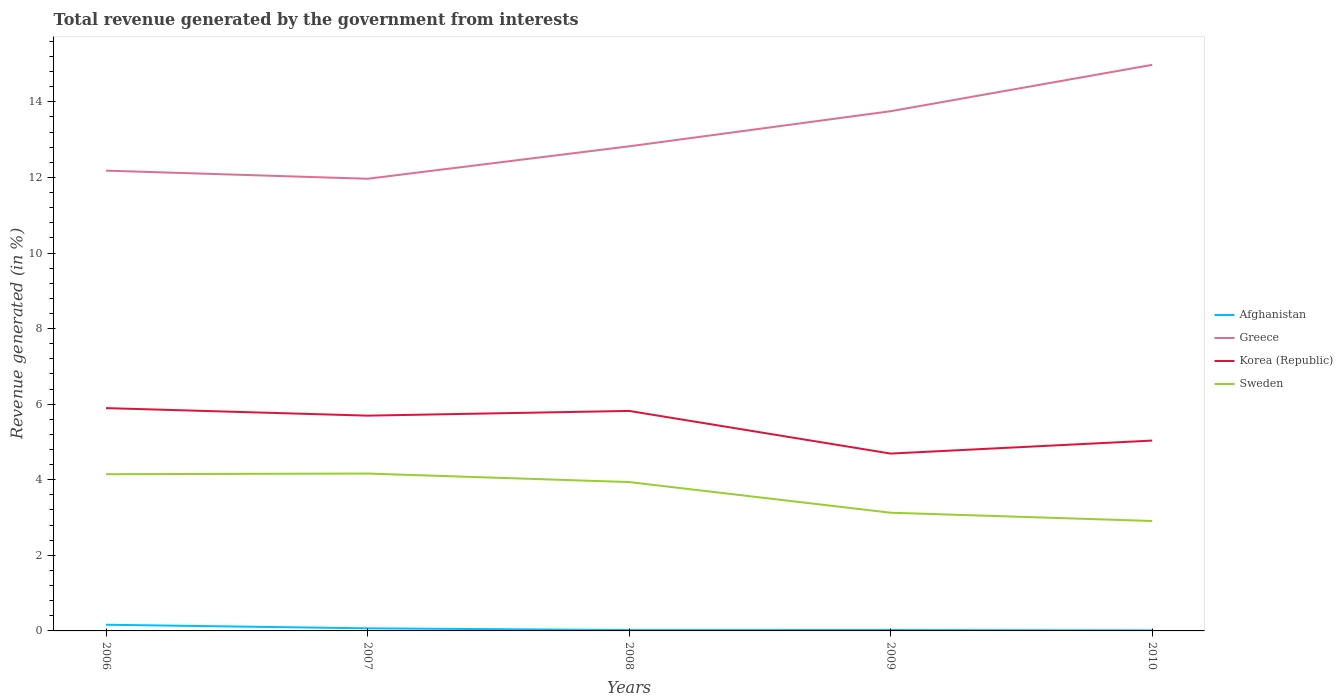Is the number of lines equal to the number of legend labels?
Give a very brief answer. Yes. Across all years, what is the maximum total revenue generated in Afghanistan?
Your response must be concise. 0.01. What is the total total revenue generated in Sweden in the graph?
Your response must be concise. 0.23. What is the difference between the highest and the second highest total revenue generated in Afghanistan?
Provide a succinct answer. 0.15. Is the total revenue generated in Greece strictly greater than the total revenue generated in Sweden over the years?
Your answer should be very brief. No. What is the difference between two consecutive major ticks on the Y-axis?
Offer a very short reply. 2. Are the values on the major ticks of Y-axis written in scientific E-notation?
Make the answer very short. No. Does the graph contain any zero values?
Your answer should be very brief. No. Does the graph contain grids?
Your answer should be very brief. No. Where does the legend appear in the graph?
Your response must be concise. Center right. How many legend labels are there?
Keep it short and to the point. 4. How are the legend labels stacked?
Make the answer very short. Vertical. What is the title of the graph?
Your answer should be compact. Total revenue generated by the government from interests. Does "Iran" appear as one of the legend labels in the graph?
Offer a terse response. No. What is the label or title of the X-axis?
Make the answer very short. Years. What is the label or title of the Y-axis?
Your answer should be compact. Revenue generated (in %). What is the Revenue generated (in %) of Afghanistan in 2006?
Make the answer very short. 0.16. What is the Revenue generated (in %) in Greece in 2006?
Give a very brief answer. 12.18. What is the Revenue generated (in %) of Korea (Republic) in 2006?
Your answer should be compact. 5.9. What is the Revenue generated (in %) of Sweden in 2006?
Provide a succinct answer. 4.15. What is the Revenue generated (in %) in Afghanistan in 2007?
Make the answer very short. 0.07. What is the Revenue generated (in %) of Greece in 2007?
Offer a very short reply. 11.96. What is the Revenue generated (in %) of Korea (Republic) in 2007?
Your response must be concise. 5.7. What is the Revenue generated (in %) of Sweden in 2007?
Offer a very short reply. 4.16. What is the Revenue generated (in %) in Afghanistan in 2008?
Offer a very short reply. 0.02. What is the Revenue generated (in %) in Greece in 2008?
Offer a very short reply. 12.82. What is the Revenue generated (in %) in Korea (Republic) in 2008?
Make the answer very short. 5.82. What is the Revenue generated (in %) of Sweden in 2008?
Make the answer very short. 3.94. What is the Revenue generated (in %) in Afghanistan in 2009?
Ensure brevity in your answer.  0.02. What is the Revenue generated (in %) of Greece in 2009?
Offer a very short reply. 13.75. What is the Revenue generated (in %) in Korea (Republic) in 2009?
Your response must be concise. 4.69. What is the Revenue generated (in %) of Sweden in 2009?
Give a very brief answer. 3.13. What is the Revenue generated (in %) of Afghanistan in 2010?
Ensure brevity in your answer.  0.01. What is the Revenue generated (in %) in Greece in 2010?
Keep it short and to the point. 14.98. What is the Revenue generated (in %) of Korea (Republic) in 2010?
Provide a succinct answer. 5.04. What is the Revenue generated (in %) of Sweden in 2010?
Offer a terse response. 2.91. Across all years, what is the maximum Revenue generated (in %) of Afghanistan?
Make the answer very short. 0.16. Across all years, what is the maximum Revenue generated (in %) in Greece?
Give a very brief answer. 14.98. Across all years, what is the maximum Revenue generated (in %) of Korea (Republic)?
Your response must be concise. 5.9. Across all years, what is the maximum Revenue generated (in %) of Sweden?
Ensure brevity in your answer.  4.16. Across all years, what is the minimum Revenue generated (in %) of Afghanistan?
Offer a very short reply. 0.01. Across all years, what is the minimum Revenue generated (in %) of Greece?
Your response must be concise. 11.96. Across all years, what is the minimum Revenue generated (in %) in Korea (Republic)?
Your answer should be compact. 4.69. Across all years, what is the minimum Revenue generated (in %) in Sweden?
Make the answer very short. 2.91. What is the total Revenue generated (in %) in Afghanistan in the graph?
Your answer should be compact. 0.29. What is the total Revenue generated (in %) of Greece in the graph?
Provide a succinct answer. 65.7. What is the total Revenue generated (in %) of Korea (Republic) in the graph?
Provide a short and direct response. 27.14. What is the total Revenue generated (in %) in Sweden in the graph?
Provide a succinct answer. 18.29. What is the difference between the Revenue generated (in %) in Afghanistan in 2006 and that in 2007?
Keep it short and to the point. 0.1. What is the difference between the Revenue generated (in %) in Greece in 2006 and that in 2007?
Provide a short and direct response. 0.21. What is the difference between the Revenue generated (in %) in Korea (Republic) in 2006 and that in 2007?
Offer a terse response. 0.2. What is the difference between the Revenue generated (in %) in Sweden in 2006 and that in 2007?
Give a very brief answer. -0.02. What is the difference between the Revenue generated (in %) of Afghanistan in 2006 and that in 2008?
Offer a very short reply. 0.14. What is the difference between the Revenue generated (in %) of Greece in 2006 and that in 2008?
Give a very brief answer. -0.64. What is the difference between the Revenue generated (in %) of Korea (Republic) in 2006 and that in 2008?
Your response must be concise. 0.07. What is the difference between the Revenue generated (in %) of Sweden in 2006 and that in 2008?
Your response must be concise. 0.21. What is the difference between the Revenue generated (in %) in Afghanistan in 2006 and that in 2009?
Offer a very short reply. 0.14. What is the difference between the Revenue generated (in %) in Greece in 2006 and that in 2009?
Your answer should be compact. -1.57. What is the difference between the Revenue generated (in %) of Korea (Republic) in 2006 and that in 2009?
Make the answer very short. 1.2. What is the difference between the Revenue generated (in %) of Afghanistan in 2006 and that in 2010?
Offer a terse response. 0.15. What is the difference between the Revenue generated (in %) in Greece in 2006 and that in 2010?
Offer a very short reply. -2.8. What is the difference between the Revenue generated (in %) of Korea (Republic) in 2006 and that in 2010?
Make the answer very short. 0.86. What is the difference between the Revenue generated (in %) in Sweden in 2006 and that in 2010?
Provide a short and direct response. 1.24. What is the difference between the Revenue generated (in %) of Afghanistan in 2007 and that in 2008?
Your answer should be very brief. 0.05. What is the difference between the Revenue generated (in %) in Greece in 2007 and that in 2008?
Provide a succinct answer. -0.86. What is the difference between the Revenue generated (in %) of Korea (Republic) in 2007 and that in 2008?
Keep it short and to the point. -0.12. What is the difference between the Revenue generated (in %) of Sweden in 2007 and that in 2008?
Your answer should be compact. 0.23. What is the difference between the Revenue generated (in %) of Afghanistan in 2007 and that in 2009?
Give a very brief answer. 0.04. What is the difference between the Revenue generated (in %) of Greece in 2007 and that in 2009?
Provide a succinct answer. -1.79. What is the difference between the Revenue generated (in %) in Korea (Republic) in 2007 and that in 2009?
Your response must be concise. 1. What is the difference between the Revenue generated (in %) of Sweden in 2007 and that in 2009?
Provide a short and direct response. 1.04. What is the difference between the Revenue generated (in %) in Afghanistan in 2007 and that in 2010?
Your response must be concise. 0.05. What is the difference between the Revenue generated (in %) of Greece in 2007 and that in 2010?
Offer a very short reply. -3.01. What is the difference between the Revenue generated (in %) of Korea (Republic) in 2007 and that in 2010?
Ensure brevity in your answer.  0.66. What is the difference between the Revenue generated (in %) in Sweden in 2007 and that in 2010?
Make the answer very short. 1.26. What is the difference between the Revenue generated (in %) in Afghanistan in 2008 and that in 2009?
Offer a terse response. -0. What is the difference between the Revenue generated (in %) of Greece in 2008 and that in 2009?
Provide a succinct answer. -0.93. What is the difference between the Revenue generated (in %) in Korea (Republic) in 2008 and that in 2009?
Offer a very short reply. 1.13. What is the difference between the Revenue generated (in %) in Sweden in 2008 and that in 2009?
Your answer should be compact. 0.81. What is the difference between the Revenue generated (in %) in Afghanistan in 2008 and that in 2010?
Offer a terse response. 0.01. What is the difference between the Revenue generated (in %) of Greece in 2008 and that in 2010?
Give a very brief answer. -2.16. What is the difference between the Revenue generated (in %) in Korea (Republic) in 2008 and that in 2010?
Offer a terse response. 0.78. What is the difference between the Revenue generated (in %) in Sweden in 2008 and that in 2010?
Your response must be concise. 1.03. What is the difference between the Revenue generated (in %) in Afghanistan in 2009 and that in 2010?
Your answer should be compact. 0.01. What is the difference between the Revenue generated (in %) of Greece in 2009 and that in 2010?
Your response must be concise. -1.23. What is the difference between the Revenue generated (in %) of Korea (Republic) in 2009 and that in 2010?
Your response must be concise. -0.34. What is the difference between the Revenue generated (in %) of Sweden in 2009 and that in 2010?
Offer a very short reply. 0.22. What is the difference between the Revenue generated (in %) in Afghanistan in 2006 and the Revenue generated (in %) in Greece in 2007?
Keep it short and to the point. -11.8. What is the difference between the Revenue generated (in %) in Afghanistan in 2006 and the Revenue generated (in %) in Korea (Republic) in 2007?
Your answer should be compact. -5.53. What is the difference between the Revenue generated (in %) in Afghanistan in 2006 and the Revenue generated (in %) in Sweden in 2007?
Keep it short and to the point. -4. What is the difference between the Revenue generated (in %) in Greece in 2006 and the Revenue generated (in %) in Korea (Republic) in 2007?
Keep it short and to the point. 6.48. What is the difference between the Revenue generated (in %) of Greece in 2006 and the Revenue generated (in %) of Sweden in 2007?
Your answer should be very brief. 8.01. What is the difference between the Revenue generated (in %) of Korea (Republic) in 2006 and the Revenue generated (in %) of Sweden in 2007?
Your answer should be very brief. 1.73. What is the difference between the Revenue generated (in %) in Afghanistan in 2006 and the Revenue generated (in %) in Greece in 2008?
Ensure brevity in your answer.  -12.66. What is the difference between the Revenue generated (in %) of Afghanistan in 2006 and the Revenue generated (in %) of Korea (Republic) in 2008?
Your answer should be compact. -5.66. What is the difference between the Revenue generated (in %) of Afghanistan in 2006 and the Revenue generated (in %) of Sweden in 2008?
Provide a succinct answer. -3.77. What is the difference between the Revenue generated (in %) of Greece in 2006 and the Revenue generated (in %) of Korea (Republic) in 2008?
Your answer should be very brief. 6.36. What is the difference between the Revenue generated (in %) of Greece in 2006 and the Revenue generated (in %) of Sweden in 2008?
Your response must be concise. 8.24. What is the difference between the Revenue generated (in %) in Korea (Republic) in 2006 and the Revenue generated (in %) in Sweden in 2008?
Offer a very short reply. 1.96. What is the difference between the Revenue generated (in %) of Afghanistan in 2006 and the Revenue generated (in %) of Greece in 2009?
Give a very brief answer. -13.59. What is the difference between the Revenue generated (in %) in Afghanistan in 2006 and the Revenue generated (in %) in Korea (Republic) in 2009?
Ensure brevity in your answer.  -4.53. What is the difference between the Revenue generated (in %) in Afghanistan in 2006 and the Revenue generated (in %) in Sweden in 2009?
Provide a short and direct response. -2.96. What is the difference between the Revenue generated (in %) of Greece in 2006 and the Revenue generated (in %) of Korea (Republic) in 2009?
Your answer should be compact. 7.49. What is the difference between the Revenue generated (in %) in Greece in 2006 and the Revenue generated (in %) in Sweden in 2009?
Keep it short and to the point. 9.05. What is the difference between the Revenue generated (in %) of Korea (Republic) in 2006 and the Revenue generated (in %) of Sweden in 2009?
Provide a short and direct response. 2.77. What is the difference between the Revenue generated (in %) of Afghanistan in 2006 and the Revenue generated (in %) of Greece in 2010?
Offer a very short reply. -14.81. What is the difference between the Revenue generated (in %) in Afghanistan in 2006 and the Revenue generated (in %) in Korea (Republic) in 2010?
Your answer should be compact. -4.87. What is the difference between the Revenue generated (in %) of Afghanistan in 2006 and the Revenue generated (in %) of Sweden in 2010?
Provide a succinct answer. -2.75. What is the difference between the Revenue generated (in %) of Greece in 2006 and the Revenue generated (in %) of Korea (Republic) in 2010?
Your response must be concise. 7.14. What is the difference between the Revenue generated (in %) of Greece in 2006 and the Revenue generated (in %) of Sweden in 2010?
Your response must be concise. 9.27. What is the difference between the Revenue generated (in %) in Korea (Republic) in 2006 and the Revenue generated (in %) in Sweden in 2010?
Provide a succinct answer. 2.99. What is the difference between the Revenue generated (in %) in Afghanistan in 2007 and the Revenue generated (in %) in Greece in 2008?
Your response must be concise. -12.75. What is the difference between the Revenue generated (in %) of Afghanistan in 2007 and the Revenue generated (in %) of Korea (Republic) in 2008?
Your response must be concise. -5.75. What is the difference between the Revenue generated (in %) in Afghanistan in 2007 and the Revenue generated (in %) in Sweden in 2008?
Your answer should be compact. -3.87. What is the difference between the Revenue generated (in %) of Greece in 2007 and the Revenue generated (in %) of Korea (Republic) in 2008?
Your response must be concise. 6.14. What is the difference between the Revenue generated (in %) in Greece in 2007 and the Revenue generated (in %) in Sweden in 2008?
Offer a very short reply. 8.03. What is the difference between the Revenue generated (in %) in Korea (Republic) in 2007 and the Revenue generated (in %) in Sweden in 2008?
Your answer should be compact. 1.76. What is the difference between the Revenue generated (in %) in Afghanistan in 2007 and the Revenue generated (in %) in Greece in 2009?
Offer a very short reply. -13.68. What is the difference between the Revenue generated (in %) in Afghanistan in 2007 and the Revenue generated (in %) in Korea (Republic) in 2009?
Your response must be concise. -4.62. What is the difference between the Revenue generated (in %) in Afghanistan in 2007 and the Revenue generated (in %) in Sweden in 2009?
Your response must be concise. -3.06. What is the difference between the Revenue generated (in %) of Greece in 2007 and the Revenue generated (in %) of Korea (Republic) in 2009?
Make the answer very short. 7.27. What is the difference between the Revenue generated (in %) of Greece in 2007 and the Revenue generated (in %) of Sweden in 2009?
Make the answer very short. 8.84. What is the difference between the Revenue generated (in %) of Korea (Republic) in 2007 and the Revenue generated (in %) of Sweden in 2009?
Offer a very short reply. 2.57. What is the difference between the Revenue generated (in %) in Afghanistan in 2007 and the Revenue generated (in %) in Greece in 2010?
Ensure brevity in your answer.  -14.91. What is the difference between the Revenue generated (in %) in Afghanistan in 2007 and the Revenue generated (in %) in Korea (Republic) in 2010?
Offer a terse response. -4.97. What is the difference between the Revenue generated (in %) of Afghanistan in 2007 and the Revenue generated (in %) of Sweden in 2010?
Your answer should be very brief. -2.84. What is the difference between the Revenue generated (in %) of Greece in 2007 and the Revenue generated (in %) of Korea (Republic) in 2010?
Give a very brief answer. 6.93. What is the difference between the Revenue generated (in %) of Greece in 2007 and the Revenue generated (in %) of Sweden in 2010?
Your response must be concise. 9.06. What is the difference between the Revenue generated (in %) in Korea (Republic) in 2007 and the Revenue generated (in %) in Sweden in 2010?
Your answer should be compact. 2.79. What is the difference between the Revenue generated (in %) in Afghanistan in 2008 and the Revenue generated (in %) in Greece in 2009?
Give a very brief answer. -13.73. What is the difference between the Revenue generated (in %) in Afghanistan in 2008 and the Revenue generated (in %) in Korea (Republic) in 2009?
Your response must be concise. -4.67. What is the difference between the Revenue generated (in %) of Afghanistan in 2008 and the Revenue generated (in %) of Sweden in 2009?
Provide a succinct answer. -3.1. What is the difference between the Revenue generated (in %) in Greece in 2008 and the Revenue generated (in %) in Korea (Republic) in 2009?
Ensure brevity in your answer.  8.13. What is the difference between the Revenue generated (in %) in Greece in 2008 and the Revenue generated (in %) in Sweden in 2009?
Your answer should be compact. 9.69. What is the difference between the Revenue generated (in %) of Korea (Republic) in 2008 and the Revenue generated (in %) of Sweden in 2009?
Your answer should be compact. 2.69. What is the difference between the Revenue generated (in %) of Afghanistan in 2008 and the Revenue generated (in %) of Greece in 2010?
Your answer should be compact. -14.96. What is the difference between the Revenue generated (in %) of Afghanistan in 2008 and the Revenue generated (in %) of Korea (Republic) in 2010?
Give a very brief answer. -5.01. What is the difference between the Revenue generated (in %) of Afghanistan in 2008 and the Revenue generated (in %) of Sweden in 2010?
Offer a terse response. -2.89. What is the difference between the Revenue generated (in %) in Greece in 2008 and the Revenue generated (in %) in Korea (Republic) in 2010?
Provide a succinct answer. 7.79. What is the difference between the Revenue generated (in %) in Greece in 2008 and the Revenue generated (in %) in Sweden in 2010?
Offer a terse response. 9.91. What is the difference between the Revenue generated (in %) of Korea (Republic) in 2008 and the Revenue generated (in %) of Sweden in 2010?
Offer a very short reply. 2.91. What is the difference between the Revenue generated (in %) in Afghanistan in 2009 and the Revenue generated (in %) in Greece in 2010?
Give a very brief answer. -14.95. What is the difference between the Revenue generated (in %) of Afghanistan in 2009 and the Revenue generated (in %) of Korea (Republic) in 2010?
Keep it short and to the point. -5.01. What is the difference between the Revenue generated (in %) of Afghanistan in 2009 and the Revenue generated (in %) of Sweden in 2010?
Give a very brief answer. -2.88. What is the difference between the Revenue generated (in %) of Greece in 2009 and the Revenue generated (in %) of Korea (Republic) in 2010?
Keep it short and to the point. 8.72. What is the difference between the Revenue generated (in %) of Greece in 2009 and the Revenue generated (in %) of Sweden in 2010?
Keep it short and to the point. 10.84. What is the difference between the Revenue generated (in %) in Korea (Republic) in 2009 and the Revenue generated (in %) in Sweden in 2010?
Keep it short and to the point. 1.78. What is the average Revenue generated (in %) in Afghanistan per year?
Your response must be concise. 0.06. What is the average Revenue generated (in %) in Greece per year?
Make the answer very short. 13.14. What is the average Revenue generated (in %) in Korea (Republic) per year?
Give a very brief answer. 5.43. What is the average Revenue generated (in %) of Sweden per year?
Provide a succinct answer. 3.66. In the year 2006, what is the difference between the Revenue generated (in %) in Afghanistan and Revenue generated (in %) in Greece?
Provide a short and direct response. -12.02. In the year 2006, what is the difference between the Revenue generated (in %) in Afghanistan and Revenue generated (in %) in Korea (Republic)?
Your answer should be compact. -5.73. In the year 2006, what is the difference between the Revenue generated (in %) of Afghanistan and Revenue generated (in %) of Sweden?
Your answer should be compact. -3.98. In the year 2006, what is the difference between the Revenue generated (in %) of Greece and Revenue generated (in %) of Korea (Republic)?
Provide a short and direct response. 6.28. In the year 2006, what is the difference between the Revenue generated (in %) in Greece and Revenue generated (in %) in Sweden?
Keep it short and to the point. 8.03. In the year 2006, what is the difference between the Revenue generated (in %) of Korea (Republic) and Revenue generated (in %) of Sweden?
Your answer should be very brief. 1.75. In the year 2007, what is the difference between the Revenue generated (in %) of Afghanistan and Revenue generated (in %) of Greece?
Offer a very short reply. -11.9. In the year 2007, what is the difference between the Revenue generated (in %) in Afghanistan and Revenue generated (in %) in Korea (Republic)?
Keep it short and to the point. -5.63. In the year 2007, what is the difference between the Revenue generated (in %) in Afghanistan and Revenue generated (in %) in Sweden?
Give a very brief answer. -4.1. In the year 2007, what is the difference between the Revenue generated (in %) of Greece and Revenue generated (in %) of Korea (Republic)?
Keep it short and to the point. 6.27. In the year 2007, what is the difference between the Revenue generated (in %) in Greece and Revenue generated (in %) in Sweden?
Your response must be concise. 7.8. In the year 2007, what is the difference between the Revenue generated (in %) in Korea (Republic) and Revenue generated (in %) in Sweden?
Give a very brief answer. 1.53. In the year 2008, what is the difference between the Revenue generated (in %) of Afghanistan and Revenue generated (in %) of Greece?
Give a very brief answer. -12.8. In the year 2008, what is the difference between the Revenue generated (in %) in Afghanistan and Revenue generated (in %) in Korea (Republic)?
Your answer should be compact. -5.8. In the year 2008, what is the difference between the Revenue generated (in %) of Afghanistan and Revenue generated (in %) of Sweden?
Make the answer very short. -3.92. In the year 2008, what is the difference between the Revenue generated (in %) in Greece and Revenue generated (in %) in Korea (Republic)?
Provide a succinct answer. 7. In the year 2008, what is the difference between the Revenue generated (in %) of Greece and Revenue generated (in %) of Sweden?
Your answer should be very brief. 8.88. In the year 2008, what is the difference between the Revenue generated (in %) in Korea (Republic) and Revenue generated (in %) in Sweden?
Offer a terse response. 1.88. In the year 2009, what is the difference between the Revenue generated (in %) of Afghanistan and Revenue generated (in %) of Greece?
Ensure brevity in your answer.  -13.73. In the year 2009, what is the difference between the Revenue generated (in %) of Afghanistan and Revenue generated (in %) of Korea (Republic)?
Offer a very short reply. -4.67. In the year 2009, what is the difference between the Revenue generated (in %) in Afghanistan and Revenue generated (in %) in Sweden?
Keep it short and to the point. -3.1. In the year 2009, what is the difference between the Revenue generated (in %) in Greece and Revenue generated (in %) in Korea (Republic)?
Your answer should be compact. 9.06. In the year 2009, what is the difference between the Revenue generated (in %) in Greece and Revenue generated (in %) in Sweden?
Keep it short and to the point. 10.62. In the year 2009, what is the difference between the Revenue generated (in %) in Korea (Republic) and Revenue generated (in %) in Sweden?
Give a very brief answer. 1.56. In the year 2010, what is the difference between the Revenue generated (in %) of Afghanistan and Revenue generated (in %) of Greece?
Offer a terse response. -14.96. In the year 2010, what is the difference between the Revenue generated (in %) of Afghanistan and Revenue generated (in %) of Korea (Republic)?
Provide a succinct answer. -5.02. In the year 2010, what is the difference between the Revenue generated (in %) in Afghanistan and Revenue generated (in %) in Sweden?
Ensure brevity in your answer.  -2.89. In the year 2010, what is the difference between the Revenue generated (in %) in Greece and Revenue generated (in %) in Korea (Republic)?
Keep it short and to the point. 9.94. In the year 2010, what is the difference between the Revenue generated (in %) in Greece and Revenue generated (in %) in Sweden?
Your answer should be compact. 12.07. In the year 2010, what is the difference between the Revenue generated (in %) of Korea (Republic) and Revenue generated (in %) of Sweden?
Your answer should be compact. 2.13. What is the ratio of the Revenue generated (in %) of Afghanistan in 2006 to that in 2007?
Ensure brevity in your answer.  2.39. What is the ratio of the Revenue generated (in %) in Korea (Republic) in 2006 to that in 2007?
Your response must be concise. 1.03. What is the ratio of the Revenue generated (in %) in Afghanistan in 2006 to that in 2008?
Your answer should be compact. 7.2. What is the ratio of the Revenue generated (in %) in Greece in 2006 to that in 2008?
Provide a short and direct response. 0.95. What is the ratio of the Revenue generated (in %) of Korea (Republic) in 2006 to that in 2008?
Your answer should be compact. 1.01. What is the ratio of the Revenue generated (in %) in Sweden in 2006 to that in 2008?
Your answer should be compact. 1.05. What is the ratio of the Revenue generated (in %) in Afghanistan in 2006 to that in 2009?
Offer a terse response. 6.79. What is the ratio of the Revenue generated (in %) in Greece in 2006 to that in 2009?
Keep it short and to the point. 0.89. What is the ratio of the Revenue generated (in %) in Korea (Republic) in 2006 to that in 2009?
Offer a very short reply. 1.26. What is the ratio of the Revenue generated (in %) of Sweden in 2006 to that in 2009?
Your response must be concise. 1.33. What is the ratio of the Revenue generated (in %) of Afghanistan in 2006 to that in 2010?
Your answer should be very brief. 11.5. What is the ratio of the Revenue generated (in %) of Greece in 2006 to that in 2010?
Give a very brief answer. 0.81. What is the ratio of the Revenue generated (in %) of Korea (Republic) in 2006 to that in 2010?
Offer a terse response. 1.17. What is the ratio of the Revenue generated (in %) in Sweden in 2006 to that in 2010?
Your answer should be very brief. 1.43. What is the ratio of the Revenue generated (in %) of Afghanistan in 2007 to that in 2008?
Offer a terse response. 3.02. What is the ratio of the Revenue generated (in %) in Greece in 2007 to that in 2008?
Your answer should be very brief. 0.93. What is the ratio of the Revenue generated (in %) in Korea (Republic) in 2007 to that in 2008?
Make the answer very short. 0.98. What is the ratio of the Revenue generated (in %) in Sweden in 2007 to that in 2008?
Offer a very short reply. 1.06. What is the ratio of the Revenue generated (in %) of Afghanistan in 2007 to that in 2009?
Your response must be concise. 2.84. What is the ratio of the Revenue generated (in %) of Greece in 2007 to that in 2009?
Provide a short and direct response. 0.87. What is the ratio of the Revenue generated (in %) of Korea (Republic) in 2007 to that in 2009?
Offer a terse response. 1.21. What is the ratio of the Revenue generated (in %) of Sweden in 2007 to that in 2009?
Your answer should be compact. 1.33. What is the ratio of the Revenue generated (in %) of Afghanistan in 2007 to that in 2010?
Offer a very short reply. 4.82. What is the ratio of the Revenue generated (in %) in Greece in 2007 to that in 2010?
Make the answer very short. 0.8. What is the ratio of the Revenue generated (in %) of Korea (Republic) in 2007 to that in 2010?
Your answer should be very brief. 1.13. What is the ratio of the Revenue generated (in %) of Sweden in 2007 to that in 2010?
Provide a succinct answer. 1.43. What is the ratio of the Revenue generated (in %) of Afghanistan in 2008 to that in 2009?
Offer a terse response. 0.94. What is the ratio of the Revenue generated (in %) of Greece in 2008 to that in 2009?
Give a very brief answer. 0.93. What is the ratio of the Revenue generated (in %) in Korea (Republic) in 2008 to that in 2009?
Offer a very short reply. 1.24. What is the ratio of the Revenue generated (in %) in Sweden in 2008 to that in 2009?
Make the answer very short. 1.26. What is the ratio of the Revenue generated (in %) in Afghanistan in 2008 to that in 2010?
Offer a very short reply. 1.6. What is the ratio of the Revenue generated (in %) of Greece in 2008 to that in 2010?
Offer a very short reply. 0.86. What is the ratio of the Revenue generated (in %) in Korea (Republic) in 2008 to that in 2010?
Offer a very short reply. 1.16. What is the ratio of the Revenue generated (in %) in Sweden in 2008 to that in 2010?
Your answer should be compact. 1.35. What is the ratio of the Revenue generated (in %) of Afghanistan in 2009 to that in 2010?
Provide a succinct answer. 1.7. What is the ratio of the Revenue generated (in %) in Greece in 2009 to that in 2010?
Keep it short and to the point. 0.92. What is the ratio of the Revenue generated (in %) of Korea (Republic) in 2009 to that in 2010?
Keep it short and to the point. 0.93. What is the ratio of the Revenue generated (in %) in Sweden in 2009 to that in 2010?
Make the answer very short. 1.08. What is the difference between the highest and the second highest Revenue generated (in %) of Afghanistan?
Offer a very short reply. 0.1. What is the difference between the highest and the second highest Revenue generated (in %) in Greece?
Your answer should be compact. 1.23. What is the difference between the highest and the second highest Revenue generated (in %) of Korea (Republic)?
Your answer should be compact. 0.07. What is the difference between the highest and the second highest Revenue generated (in %) in Sweden?
Make the answer very short. 0.02. What is the difference between the highest and the lowest Revenue generated (in %) in Afghanistan?
Provide a short and direct response. 0.15. What is the difference between the highest and the lowest Revenue generated (in %) in Greece?
Your response must be concise. 3.01. What is the difference between the highest and the lowest Revenue generated (in %) in Korea (Republic)?
Offer a terse response. 1.2. What is the difference between the highest and the lowest Revenue generated (in %) of Sweden?
Ensure brevity in your answer.  1.26. 